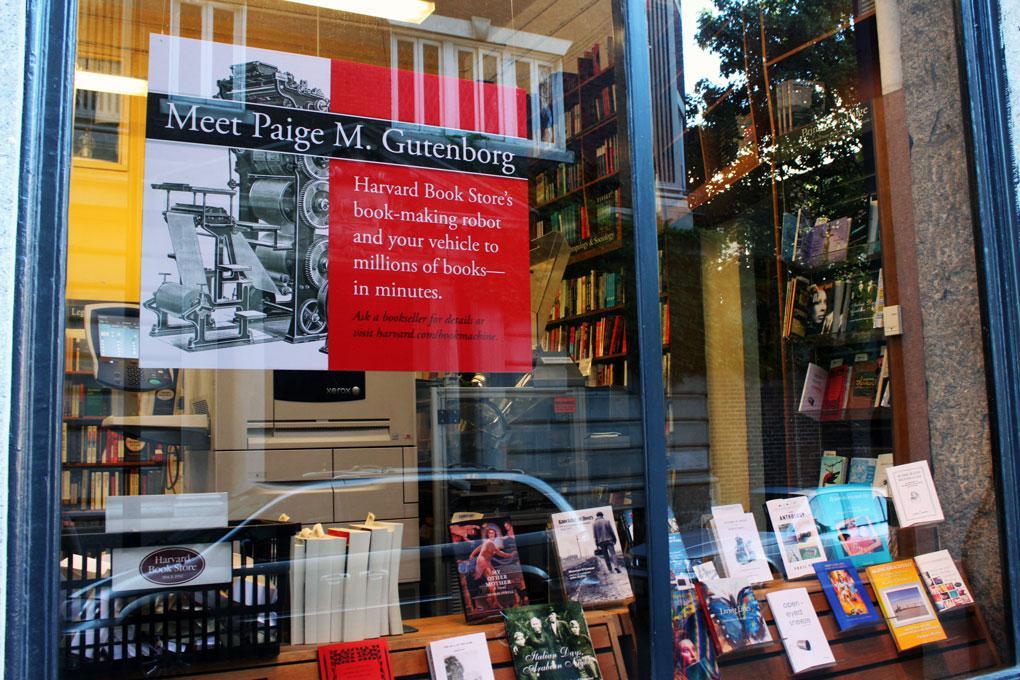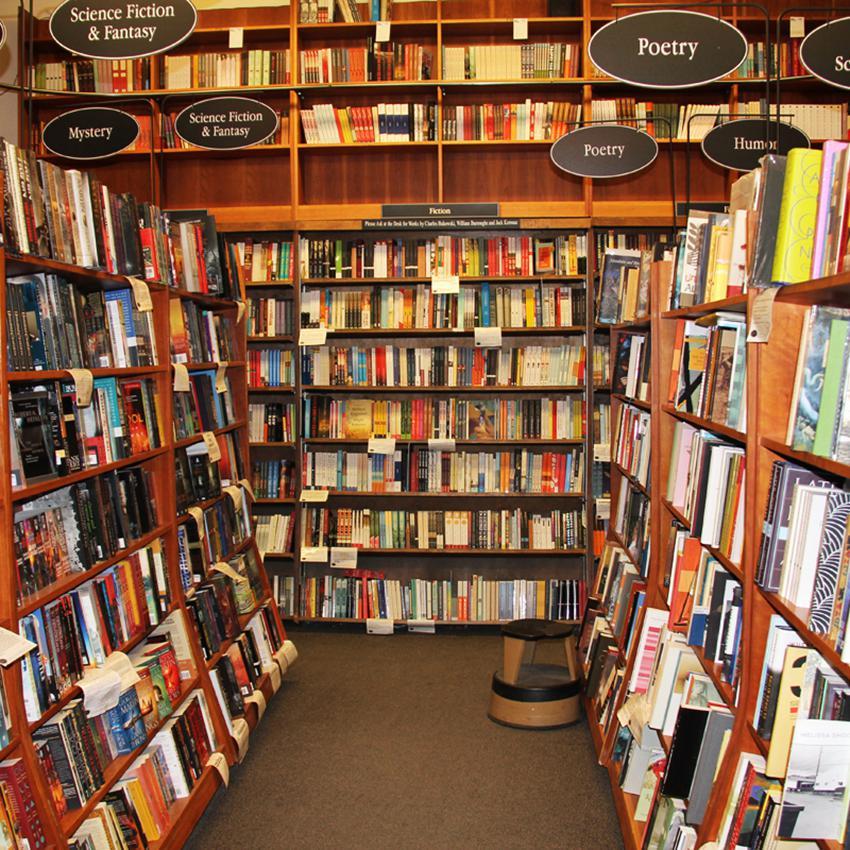The first image is the image on the left, the second image is the image on the right. For the images displayed, is the sentence "There are at least two people inside the store in the image on the right." factually correct? Answer yes or no. No. 